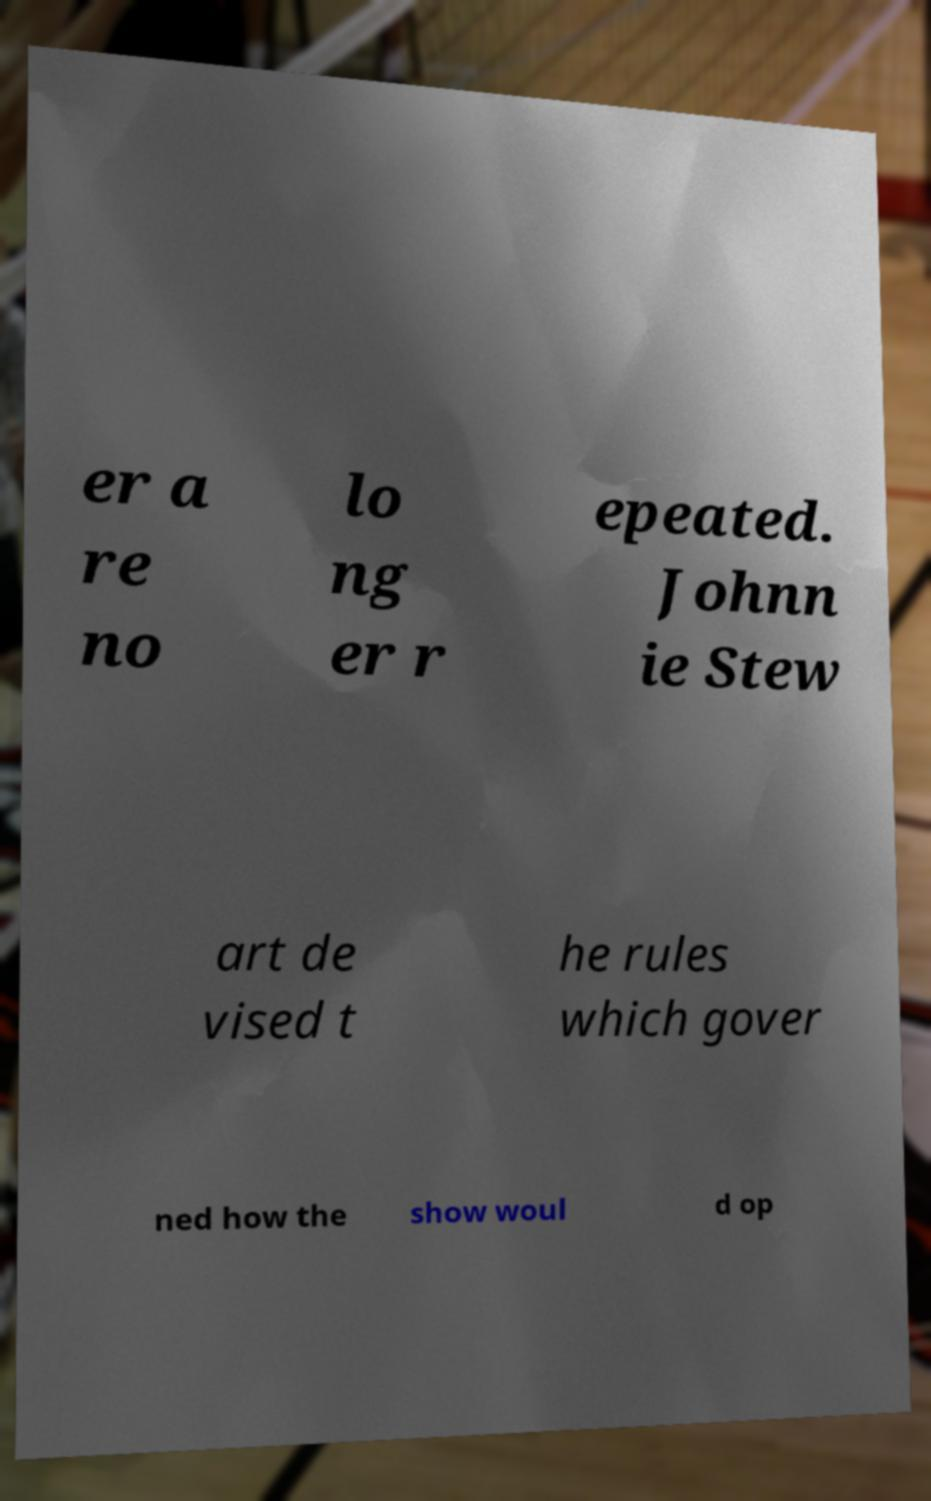Can you accurately transcribe the text from the provided image for me? er a re no lo ng er r epeated. Johnn ie Stew art de vised t he rules which gover ned how the show woul d op 